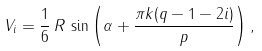<formula> <loc_0><loc_0><loc_500><loc_500>V _ { i } = \frac { 1 } { 6 } \, R \, \sin \left ( \alpha + \frac { \pi k ( q - 1 - 2 i ) } { p } \right ) ,</formula> 